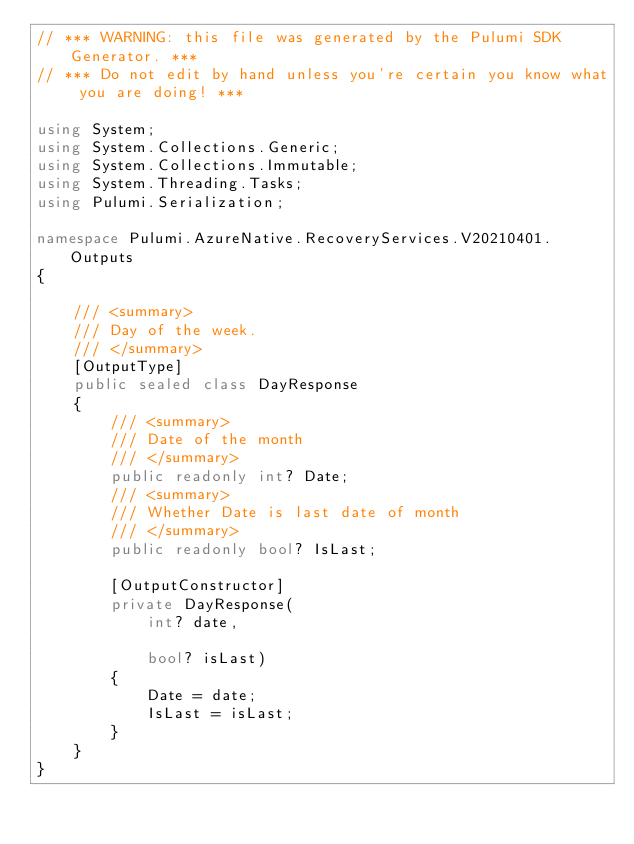<code> <loc_0><loc_0><loc_500><loc_500><_C#_>// *** WARNING: this file was generated by the Pulumi SDK Generator. ***
// *** Do not edit by hand unless you're certain you know what you are doing! ***

using System;
using System.Collections.Generic;
using System.Collections.Immutable;
using System.Threading.Tasks;
using Pulumi.Serialization;

namespace Pulumi.AzureNative.RecoveryServices.V20210401.Outputs
{

    /// <summary>
    /// Day of the week.
    /// </summary>
    [OutputType]
    public sealed class DayResponse
    {
        /// <summary>
        /// Date of the month
        /// </summary>
        public readonly int? Date;
        /// <summary>
        /// Whether Date is last date of month
        /// </summary>
        public readonly bool? IsLast;

        [OutputConstructor]
        private DayResponse(
            int? date,

            bool? isLast)
        {
            Date = date;
            IsLast = isLast;
        }
    }
}
</code> 